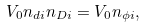<formula> <loc_0><loc_0><loc_500><loc_500>V _ { 0 } n _ { d i } n _ { D i } = V _ { 0 } n _ { \phi i } ,</formula> 